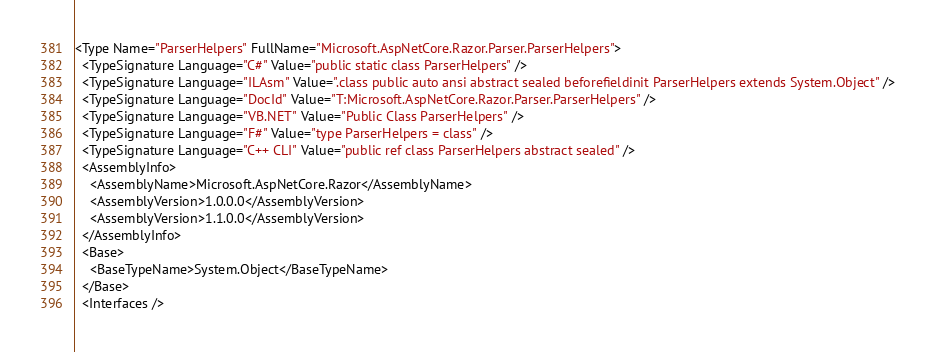<code> <loc_0><loc_0><loc_500><loc_500><_XML_><Type Name="ParserHelpers" FullName="Microsoft.AspNetCore.Razor.Parser.ParserHelpers">
  <TypeSignature Language="C#" Value="public static class ParserHelpers" />
  <TypeSignature Language="ILAsm" Value=".class public auto ansi abstract sealed beforefieldinit ParserHelpers extends System.Object" />
  <TypeSignature Language="DocId" Value="T:Microsoft.AspNetCore.Razor.Parser.ParserHelpers" />
  <TypeSignature Language="VB.NET" Value="Public Class ParserHelpers" />
  <TypeSignature Language="F#" Value="type ParserHelpers = class" />
  <TypeSignature Language="C++ CLI" Value="public ref class ParserHelpers abstract sealed" />
  <AssemblyInfo>
    <AssemblyName>Microsoft.AspNetCore.Razor</AssemblyName>
    <AssemblyVersion>1.0.0.0</AssemblyVersion>
    <AssemblyVersion>1.1.0.0</AssemblyVersion>
  </AssemblyInfo>
  <Base>
    <BaseTypeName>System.Object</BaseTypeName>
  </Base>
  <Interfaces /></code> 